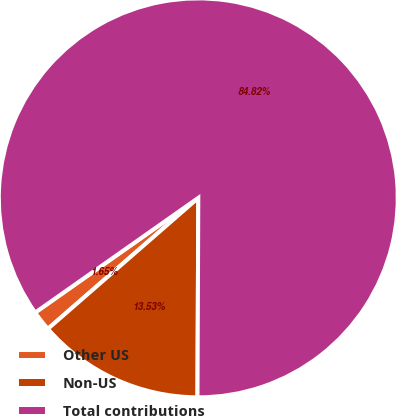<chart> <loc_0><loc_0><loc_500><loc_500><pie_chart><fcel>Other US<fcel>Non-US<fcel>Total contributions<nl><fcel>1.65%<fcel>13.53%<fcel>84.82%<nl></chart> 